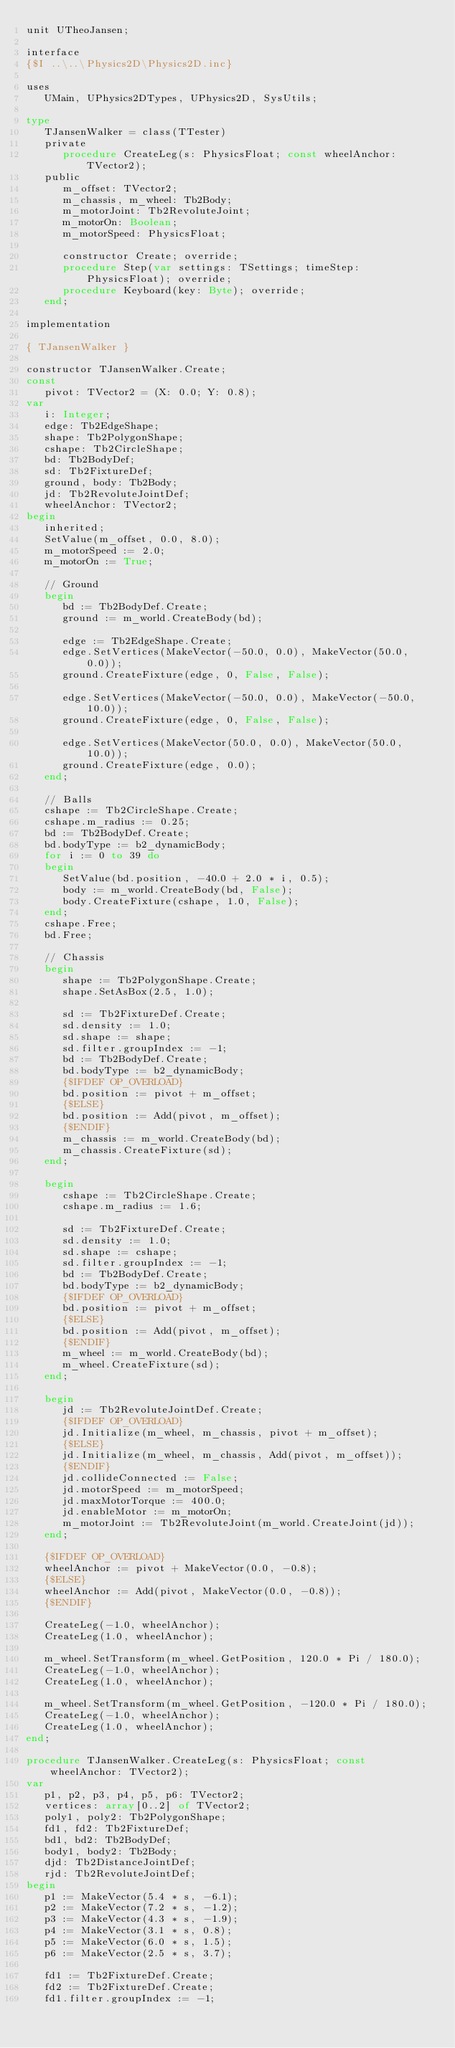<code> <loc_0><loc_0><loc_500><loc_500><_Pascal_>unit UTheoJansen;

interface
{$I ..\..\Physics2D\Physics2D.inc}

uses
   UMain, UPhysics2DTypes, UPhysics2D, SysUtils;

type
   TJansenWalker = class(TTester)
   private
      procedure CreateLeg(s: PhysicsFloat; const wheelAnchor: TVector2);
   public
      m_offset: TVector2;
      m_chassis, m_wheel: Tb2Body;
      m_motorJoint: Tb2RevoluteJoint;
      m_motorOn: Boolean;
      m_motorSpeed: PhysicsFloat;

      constructor Create; override;
      procedure Step(var settings: TSettings; timeStep: PhysicsFloat); override;
      procedure Keyboard(key: Byte); override;
   end;

implementation

{ TJansenWalker }

constructor TJansenWalker.Create;
const
   pivot: TVector2 = (X: 0.0; Y: 0.8);
var
   i: Integer;
   edge: Tb2EdgeShape;
   shape: Tb2PolygonShape;
   cshape: Tb2CircleShape;
   bd: Tb2BodyDef;
   sd: Tb2FixtureDef;
   ground, body: Tb2Body;
   jd: Tb2RevoluteJointDef;
   wheelAnchor: TVector2;
begin
   inherited;
   SetValue(m_offset, 0.0, 8.0);
   m_motorSpeed := 2.0;
   m_motorOn := True;

   // Ground
   begin
      bd := Tb2BodyDef.Create;
      ground := m_world.CreateBody(bd);

      edge := Tb2EdgeShape.Create;
      edge.SetVertices(MakeVector(-50.0, 0.0), MakeVector(50.0, 0.0));
      ground.CreateFixture(edge, 0, False, False);

      edge.SetVertices(MakeVector(-50.0, 0.0), MakeVector(-50.0, 10.0));
      ground.CreateFixture(edge, 0, False, False);

      edge.SetVertices(MakeVector(50.0, 0.0), MakeVector(50.0, 10.0));
      ground.CreateFixture(edge, 0.0);
   end;

   // Balls
   cshape := Tb2CircleShape.Create;
   cshape.m_radius := 0.25;
   bd := Tb2BodyDef.Create;
   bd.bodyType := b2_dynamicBody;
   for i := 0 to 39 do
   begin
			SetValue(bd.position, -40.0 + 2.0 * i, 0.5);
			body := m_world.CreateBody(bd, False);
			body.CreateFixture(cshape, 1.0, False);
   end;
   cshape.Free;
   bd.Free;

   // Chassis
   begin
			shape := Tb2PolygonShape.Create;
			shape.SetAsBox(2.5, 1.0);

			sd := Tb2FixtureDef.Create;
			sd.density := 1.0;
			sd.shape := shape;
			sd.filter.groupIndex := -1;
      bd := Tb2BodyDef.Create;
			bd.bodyType := b2_dynamicBody;
      {$IFDEF OP_OVERLOAD}
			bd.position := pivot + m_offset;
      {$ELSE}
      bd.position := Add(pivot, m_offset);
      {$ENDIF}
			m_chassis := m_world.CreateBody(bd);
			m_chassis.CreateFixture(sd);
   end;

   begin
			cshape := Tb2CircleShape.Create;
			cshape.m_radius := 1.6;

			sd := Tb2FixtureDef.Create;
			sd.density := 1.0;
			sd.shape := cshape;
			sd.filter.groupIndex := -1;
			bd := Tb2BodyDef.Create;
			bd.bodyType := b2_dynamicBody;
      {$IFDEF OP_OVERLOAD}
			bd.position := pivot + m_offset;
      {$ELSE}
      bd.position := Add(pivot, m_offset);
      {$ENDIF}
			m_wheel := m_world.CreateBody(bd);
			m_wheel.CreateFixture(sd);
   end;

   begin
      jd := Tb2RevoluteJointDef.Create;
      {$IFDEF OP_OVERLOAD}
      jd.Initialize(m_wheel, m_chassis, pivot + m_offset);
      {$ELSE}
      jd.Initialize(m_wheel, m_chassis, Add(pivot, m_offset));
      {$ENDIF}
      jd.collideConnected := False;
      jd.motorSpeed := m_motorSpeed;
      jd.maxMotorTorque := 400.0;
      jd.enableMotor := m_motorOn;
      m_motorJoint := Tb2RevoluteJoint(m_world.CreateJoint(jd));
   end;

   {$IFDEF OP_OVERLOAD}
   wheelAnchor := pivot + MakeVector(0.0, -0.8);
   {$ELSE}
   wheelAnchor := Add(pivot, MakeVector(0.0, -0.8));
   {$ENDIF}

   CreateLeg(-1.0, wheelAnchor);
   CreateLeg(1.0, wheelAnchor);

   m_wheel.SetTransform(m_wheel.GetPosition, 120.0 * Pi / 180.0);
   CreateLeg(-1.0, wheelAnchor);
   CreateLeg(1.0, wheelAnchor);

   m_wheel.SetTransform(m_wheel.GetPosition, -120.0 * Pi / 180.0);
   CreateLeg(-1.0, wheelAnchor);
   CreateLeg(1.0, wheelAnchor);
end;

procedure TJansenWalker.CreateLeg(s: PhysicsFloat; const wheelAnchor: TVector2);
var
   p1, p2, p3, p4, p5, p6: TVector2;
   vertices: array[0..2] of TVector2;
   poly1, poly2: Tb2PolygonShape;
   fd1, fd2: Tb2FixtureDef;
   bd1, bd2: Tb2BodyDef;
   body1, body2: Tb2Body;
   djd: Tb2DistanceJointDef;
   rjd: Tb2RevoluteJointDef;
begin
   p1 := MakeVector(5.4 * s, -6.1);
   p2 := MakeVector(7.2 * s, -1.2);
   p3 := MakeVector(4.3 * s, -1.9);
   p4 := MakeVector(3.1 * s, 0.8);
   p5 := MakeVector(6.0 * s, 1.5);
   p6 := MakeVector(2.5 * s, 3.7);

   fd1 := Tb2FixtureDef.Create;
   fd2 := Tb2FixtureDef.Create;
   fd1.filter.groupIndex := -1;</code> 